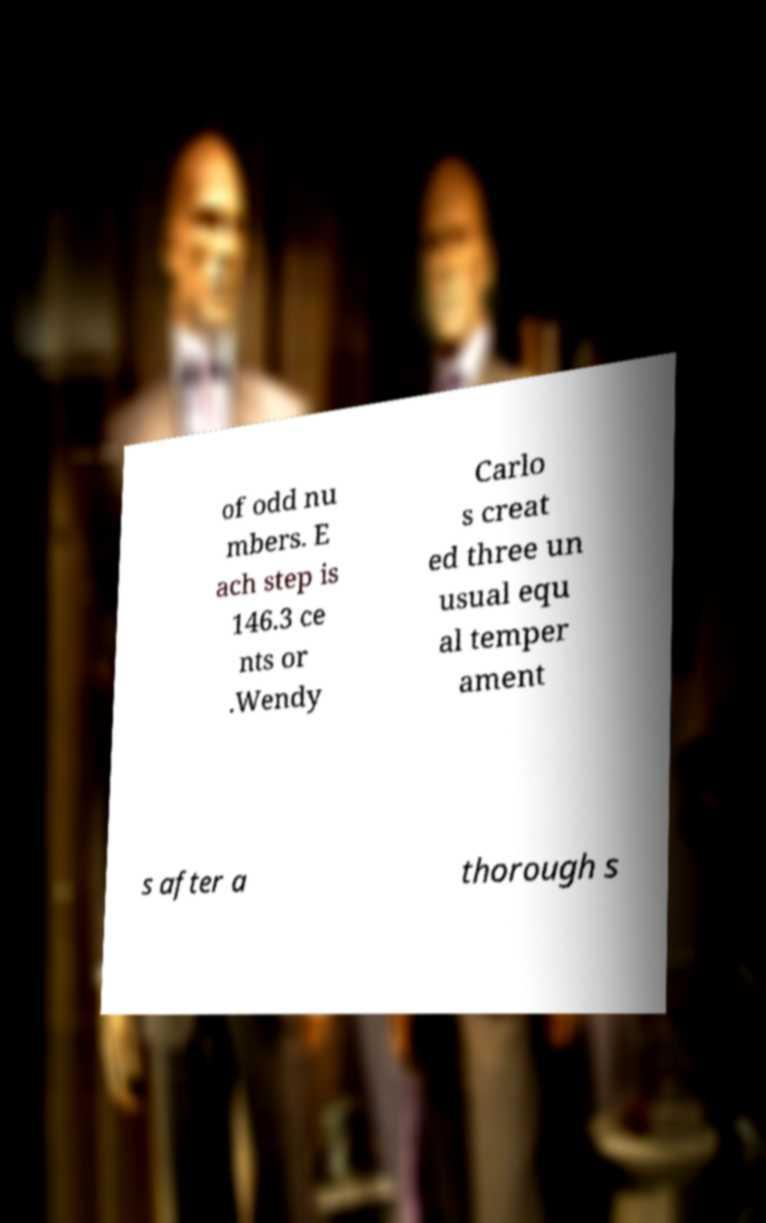Can you accurately transcribe the text from the provided image for me? of odd nu mbers. E ach step is 146.3 ce nts or .Wendy Carlo s creat ed three un usual equ al temper ament s after a thorough s 